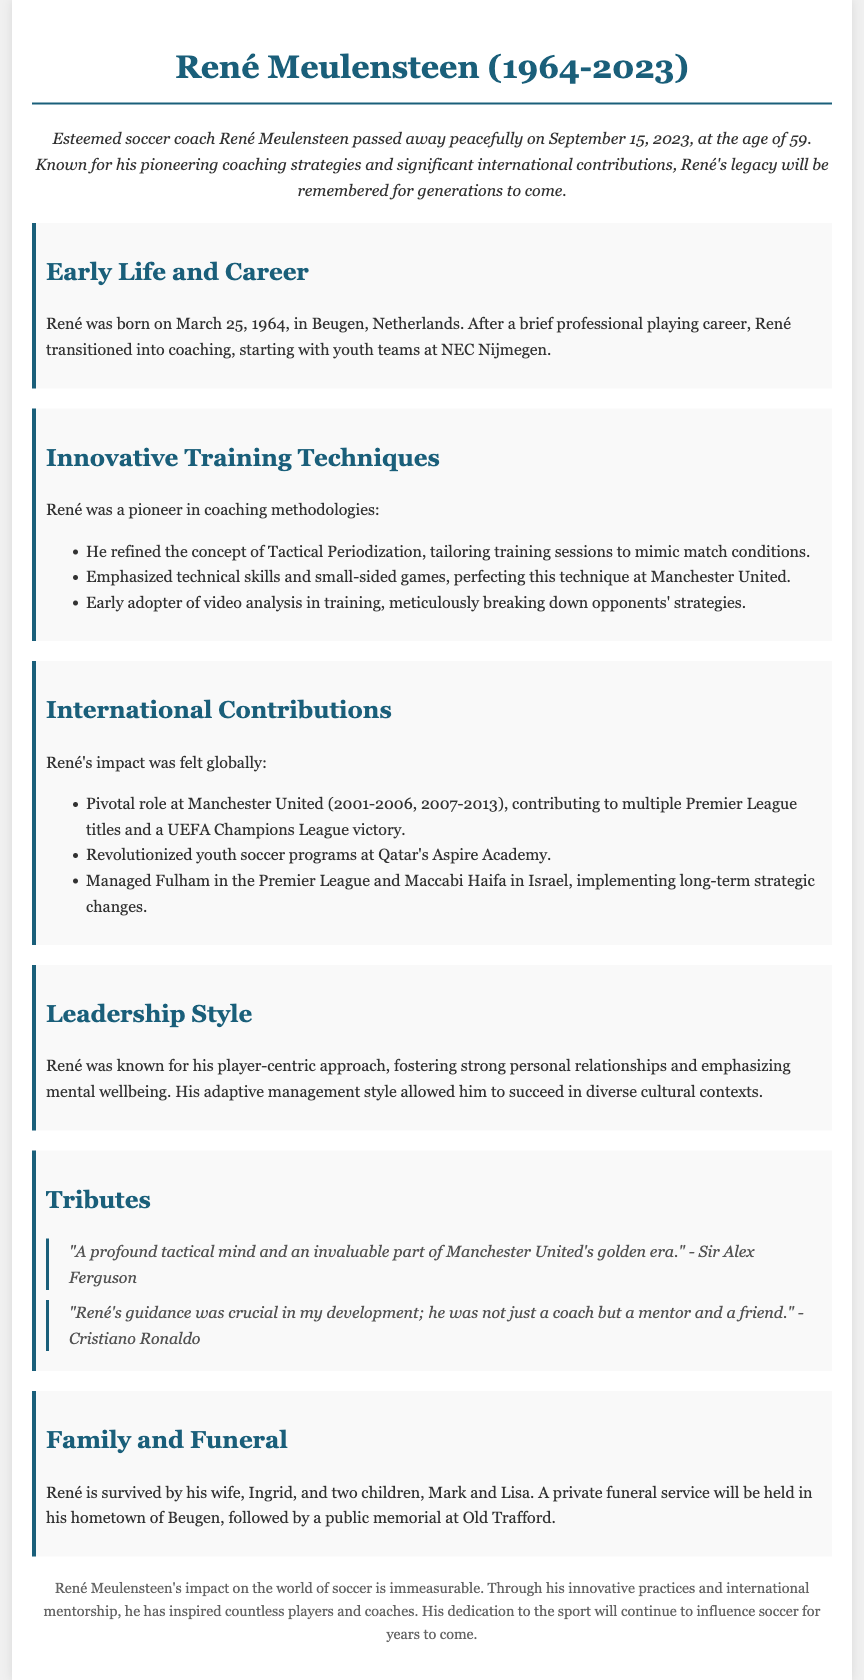what year was René Meulensteen born? The document states that René was born on March 25, 1964.
Answer: 1964 what innovative training method did René pioneer? The document mentions that René refined the concept of Tactical Periodization.
Answer: Tactical Periodization which prestigious club did René contribute to multiple Premier League titles? The document specifies his pivotal role at Manchester United contributing to multiple titles.
Answer: Manchester United how many children did René have? The document states that he is survived by two children, Mark and Lisa.
Answer: Two what was René's leadership style primarily centered on? The document describes René's leadership style as player-centric.
Answer: player-centric who described René as "a profound tactical mind"? The document quotes Sir Alex Ferguson as the individual who made this statement.
Answer: Sir Alex Ferguson what was the main focus of René’s contributions to youth soccer in Qatar? The document indicates he revolutionized youth soccer programs at Qatar's Aspire Academy.
Answer: Aspire Academy what was the date of René Meulensteen's passing? The document notes that René passed away on September 15, 2023.
Answer: September 15, 2023 